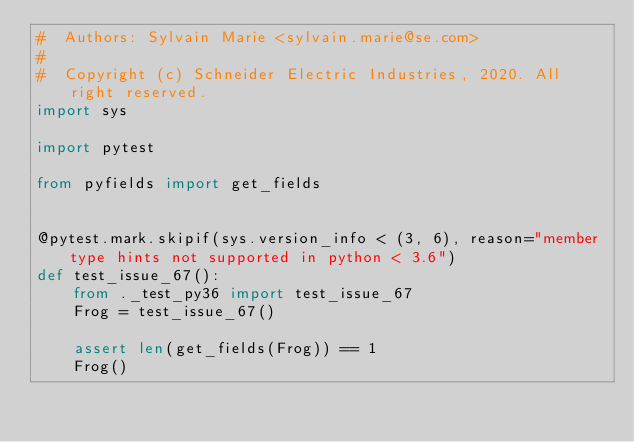Convert code to text. <code><loc_0><loc_0><loc_500><loc_500><_Python_>#  Authors: Sylvain Marie <sylvain.marie@se.com>
#
#  Copyright (c) Schneider Electric Industries, 2020. All right reserved.
import sys

import pytest

from pyfields import get_fields


@pytest.mark.skipif(sys.version_info < (3, 6), reason="member type hints not supported in python < 3.6")
def test_issue_67():
    from ._test_py36 import test_issue_67
    Frog = test_issue_67()

    assert len(get_fields(Frog)) == 1
    Frog()
</code> 